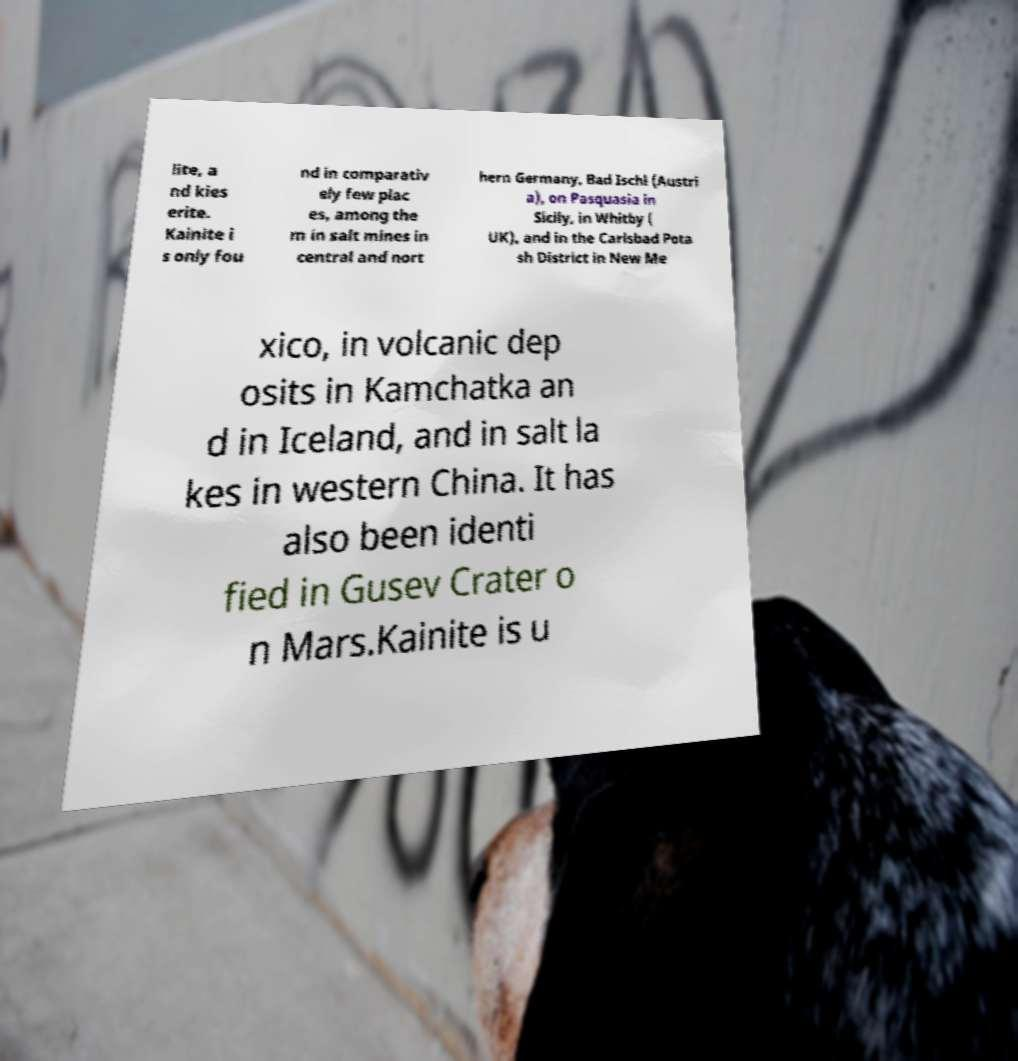Please read and relay the text visible in this image. What does it say? lite, a nd kies erite. Kainite i s only fou nd in comparativ ely few plac es, among the m in salt mines in central and nort hern Germany, Bad Ischl (Austri a), on Pasquasia in Sicily, in Whitby ( UK), and in the Carlsbad Pota sh District in New Me xico, in volcanic dep osits in Kamchatka an d in Iceland, and in salt la kes in western China. It has also been identi fied in Gusev Crater o n Mars.Kainite is u 